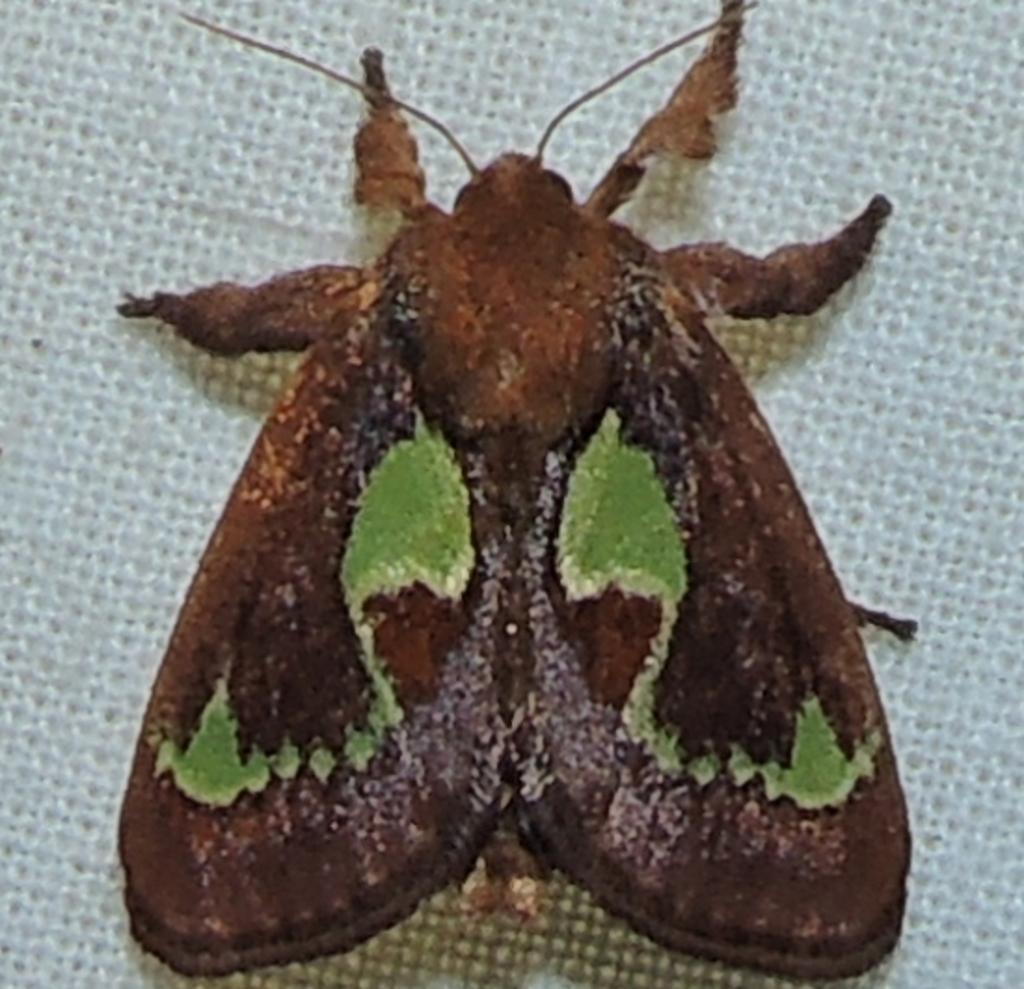Describe this image in one or two sentences. In this image I can see white colour thing and on it I can see a brown and green colour insect. 